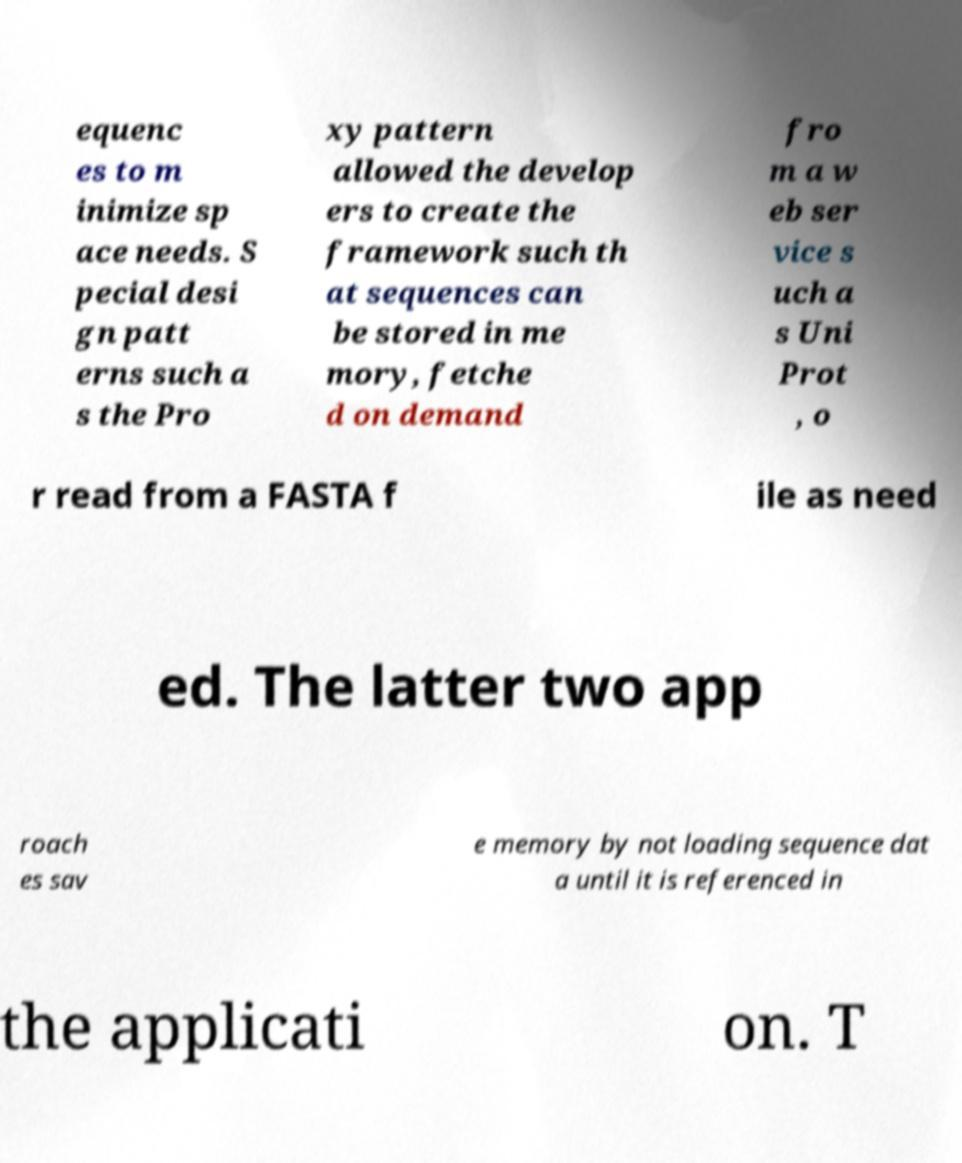I need the written content from this picture converted into text. Can you do that? equenc es to m inimize sp ace needs. S pecial desi gn patt erns such a s the Pro xy pattern allowed the develop ers to create the framework such th at sequences can be stored in me mory, fetche d on demand fro m a w eb ser vice s uch a s Uni Prot , o r read from a FASTA f ile as need ed. The latter two app roach es sav e memory by not loading sequence dat a until it is referenced in the applicati on. T 